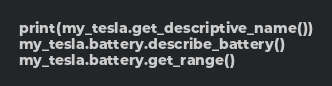<code> <loc_0><loc_0><loc_500><loc_500><_Python_>print(my_tesla.get_descriptive_name())
my_tesla.battery.describe_battery()
my_tesla.battery.get_range()
</code> 